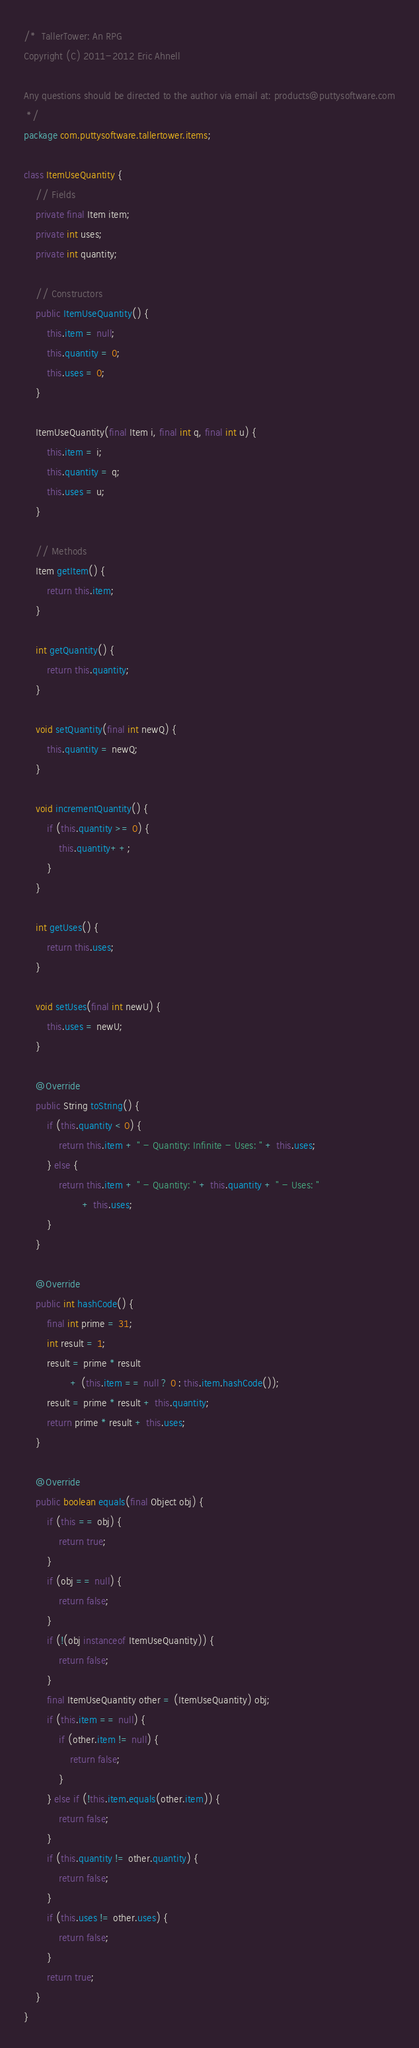<code> <loc_0><loc_0><loc_500><loc_500><_Java_>/*  TallerTower: An RPG
Copyright (C) 2011-2012 Eric Ahnell

Any questions should be directed to the author via email at: products@puttysoftware.com
 */
package com.puttysoftware.tallertower.items;

class ItemUseQuantity {
    // Fields
    private final Item item;
    private int uses;
    private int quantity;

    // Constructors
    public ItemUseQuantity() {
        this.item = null;
        this.quantity = 0;
        this.uses = 0;
    }

    ItemUseQuantity(final Item i, final int q, final int u) {
        this.item = i;
        this.quantity = q;
        this.uses = u;
    }

    // Methods
    Item getItem() {
        return this.item;
    }

    int getQuantity() {
        return this.quantity;
    }

    void setQuantity(final int newQ) {
        this.quantity = newQ;
    }

    void incrementQuantity() {
        if (this.quantity >= 0) {
            this.quantity++;
        }
    }

    int getUses() {
        return this.uses;
    }

    void setUses(final int newU) {
        this.uses = newU;
    }

    @Override
    public String toString() {
        if (this.quantity < 0) {
            return this.item + " - Quantity: Infinite - Uses: " + this.uses;
        } else {
            return this.item + " - Quantity: " + this.quantity + " - Uses: "
                    + this.uses;
        }
    }

    @Override
    public int hashCode() {
        final int prime = 31;
        int result = 1;
        result = prime * result
                + (this.item == null ? 0 : this.item.hashCode());
        result = prime * result + this.quantity;
        return prime * result + this.uses;
    }

    @Override
    public boolean equals(final Object obj) {
        if (this == obj) {
            return true;
        }
        if (obj == null) {
            return false;
        }
        if (!(obj instanceof ItemUseQuantity)) {
            return false;
        }
        final ItemUseQuantity other = (ItemUseQuantity) obj;
        if (this.item == null) {
            if (other.item != null) {
                return false;
            }
        } else if (!this.item.equals(other.item)) {
            return false;
        }
        if (this.quantity != other.quantity) {
            return false;
        }
        if (this.uses != other.uses) {
            return false;
        }
        return true;
    }
}
</code> 